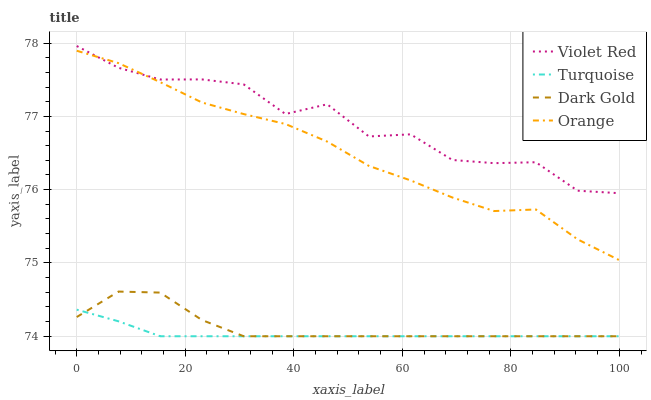Does Turquoise have the minimum area under the curve?
Answer yes or no. Yes. Does Violet Red have the maximum area under the curve?
Answer yes or no. Yes. Does Violet Red have the minimum area under the curve?
Answer yes or no. No. Does Turquoise have the maximum area under the curve?
Answer yes or no. No. Is Turquoise the smoothest?
Answer yes or no. Yes. Is Violet Red the roughest?
Answer yes or no. Yes. Is Violet Red the smoothest?
Answer yes or no. No. Is Turquoise the roughest?
Answer yes or no. No. Does Violet Red have the lowest value?
Answer yes or no. No. Does Violet Red have the highest value?
Answer yes or no. Yes. Does Turquoise have the highest value?
Answer yes or no. No. Is Dark Gold less than Violet Red?
Answer yes or no. Yes. Is Orange greater than Dark Gold?
Answer yes or no. Yes. Does Turquoise intersect Dark Gold?
Answer yes or no. Yes. Is Turquoise less than Dark Gold?
Answer yes or no. No. Is Turquoise greater than Dark Gold?
Answer yes or no. No. Does Dark Gold intersect Violet Red?
Answer yes or no. No. 